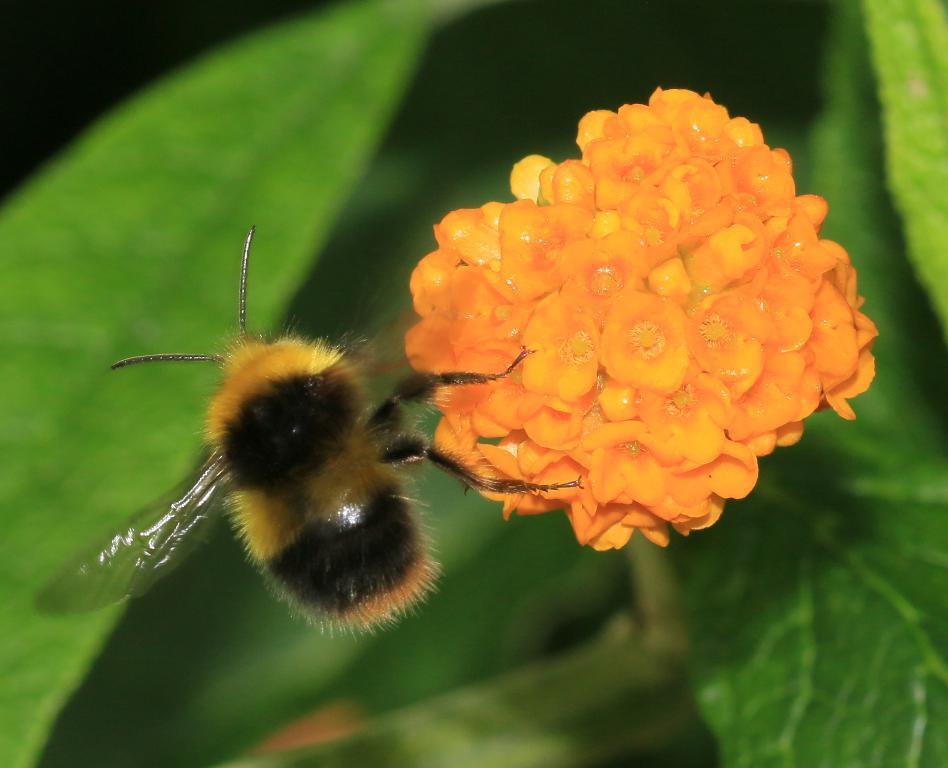Describe this image in one or two sentences. In this image we can see a flower which is in orange color and there is a honey bee. In the background there are leaves. 